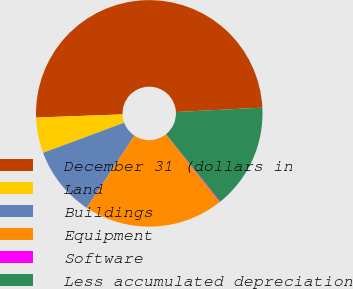<chart> <loc_0><loc_0><loc_500><loc_500><pie_chart><fcel>December 31 (dollars in<fcel>Land<fcel>Buildings<fcel>Equipment<fcel>Software<fcel>Less accumulated depreciation<nl><fcel>49.78%<fcel>5.08%<fcel>10.04%<fcel>19.98%<fcel>0.11%<fcel>15.01%<nl></chart> 